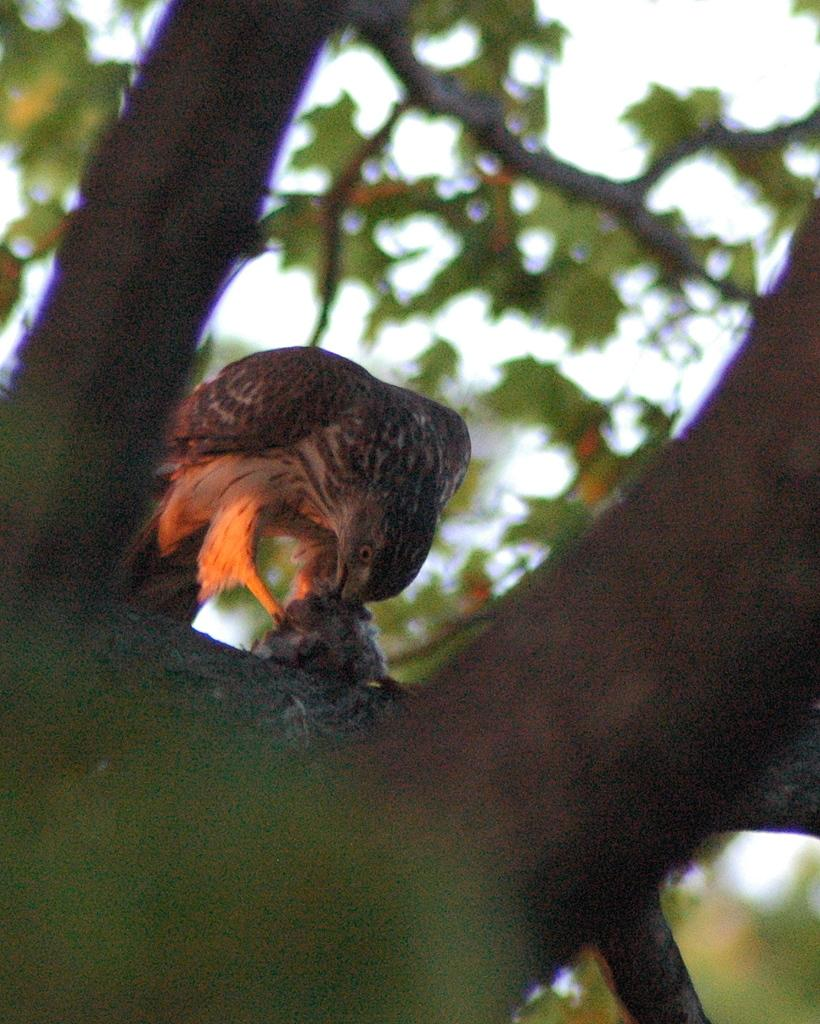What is present in the image? There is a tree and a bird on the tree in the image. Can you describe the bird's location? The bird is on the tree in the image. What can be observed about the background of the image? The background of the image is blurred. What type of whip is being used by the bird in the image? There is no whip present in the image; it features a tree with a bird on it. How does the bird turn around on the tree in the image? The bird does not turn around in the image; it is stationary on the tree. 